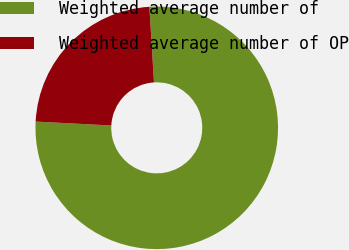Convert chart to OTSL. <chart><loc_0><loc_0><loc_500><loc_500><pie_chart><fcel>Weighted average number of<fcel>Weighted average number of OP<nl><fcel>76.79%<fcel>23.21%<nl></chart> 